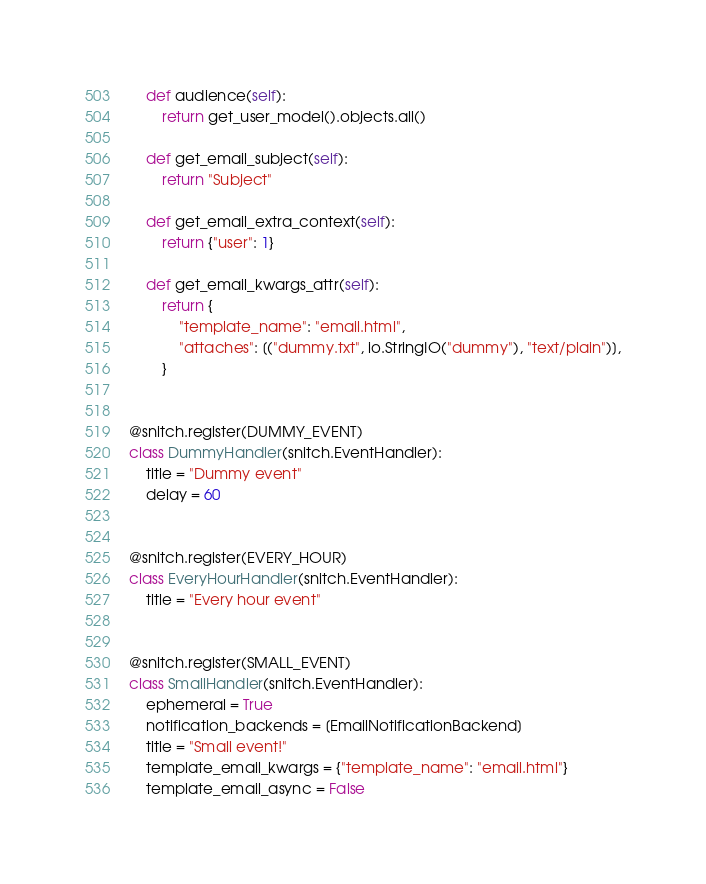Convert code to text. <code><loc_0><loc_0><loc_500><loc_500><_Python_>    def audience(self):
        return get_user_model().objects.all()

    def get_email_subject(self):
        return "Subject"

    def get_email_extra_context(self):
        return {"user": 1}

    def get_email_kwargs_attr(self):
        return {
            "template_name": "email.html",
            "attaches": [("dummy.txt", io.StringIO("dummy"), "text/plain")],
        }


@snitch.register(DUMMY_EVENT)
class DummyHandler(snitch.EventHandler):
    title = "Dummy event"
    delay = 60


@snitch.register(EVERY_HOUR)
class EveryHourHandler(snitch.EventHandler):
    title = "Every hour event"


@snitch.register(SMALL_EVENT)
class SmallHandler(snitch.EventHandler):
    ephemeral = True
    notification_backends = [EmailNotificationBackend]
    title = "Small event!"
    template_email_kwargs = {"template_name": "email.html"}
    template_email_async = False
</code> 